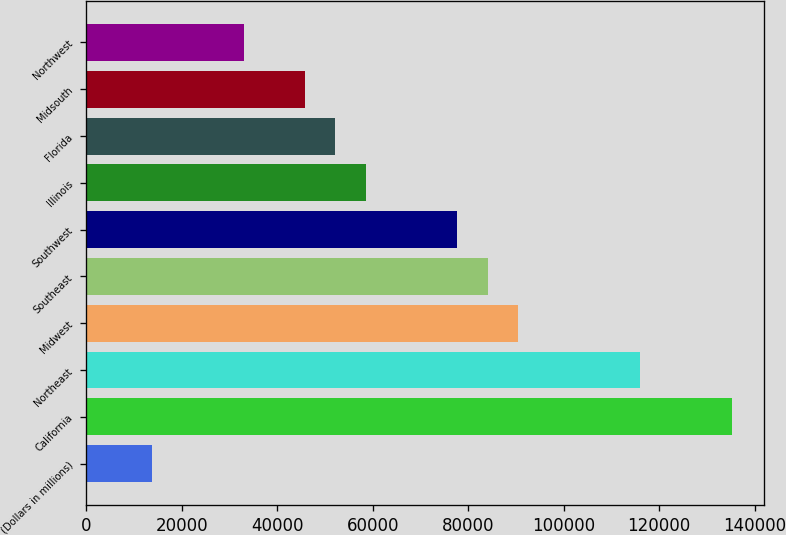Convert chart. <chart><loc_0><loc_0><loc_500><loc_500><bar_chart><fcel>(Dollars in millions)<fcel>California<fcel>Northeast<fcel>Midwest<fcel>Southeast<fcel>Southwest<fcel>Illinois<fcel>Florida<fcel>Midsouth<fcel>Northwest<nl><fcel>13764<fcel>135222<fcel>116044<fcel>90474<fcel>84081.5<fcel>77689<fcel>58511.5<fcel>52119<fcel>45726.5<fcel>32941.5<nl></chart> 